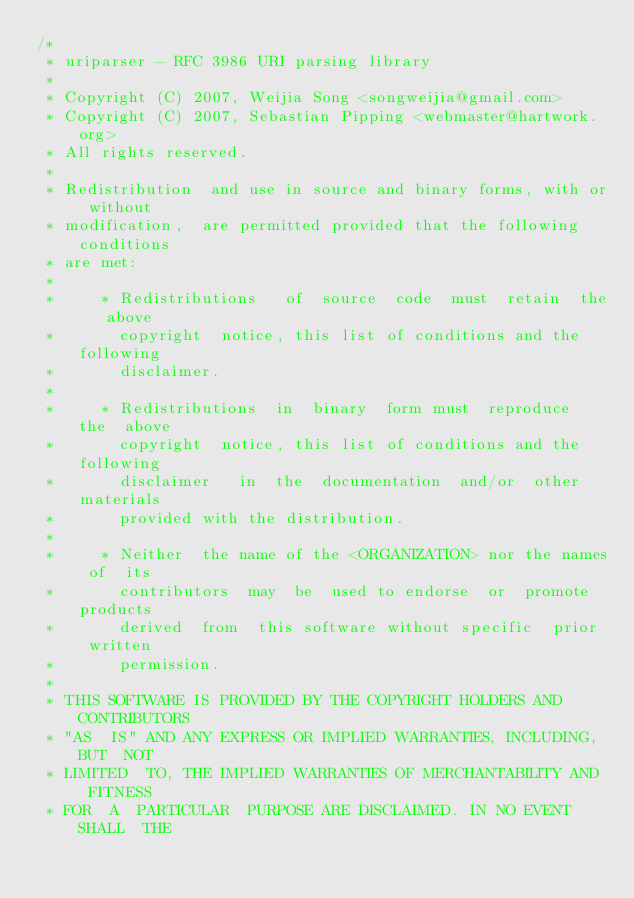Convert code to text. <code><loc_0><loc_0><loc_500><loc_500><_C_>/*
 * uriparser - RFC 3986 URI parsing library
 *
 * Copyright (C) 2007, Weijia Song <songweijia@gmail.com>
 * Copyright (C) 2007, Sebastian Pipping <webmaster@hartwork.org>
 * All rights reserved.
 *
 * Redistribution  and use in source and binary forms, with or without
 * modification,  are permitted provided that the following conditions
 * are met:
 *
 *     * Redistributions   of  source  code  must  retain  the   above
 *       copyright  notice, this list of conditions and the  following
 *       disclaimer.
 *
 *     * Redistributions  in  binary  form must  reproduce  the  above
 *       copyright  notice, this list of conditions and the  following
 *       disclaimer   in  the  documentation  and/or  other  materials
 *       provided with the distribution.
 *
 *     * Neither  the name of the <ORGANIZATION> nor the names of  its
 *       contributors  may  be  used to endorse  or  promote  products
 *       derived  from  this software without specific  prior  written
 *       permission.
 *
 * THIS SOFTWARE IS PROVIDED BY THE COPYRIGHT HOLDERS AND CONTRIBUTORS
 * "AS  IS" AND ANY EXPRESS OR IMPLIED WARRANTIES, INCLUDING, BUT  NOT
 * LIMITED  TO, THE IMPLIED WARRANTIES OF MERCHANTABILITY AND  FITNESS
 * FOR  A  PARTICULAR  PURPOSE ARE DISCLAIMED. IN NO EVENT  SHALL  THE</code> 